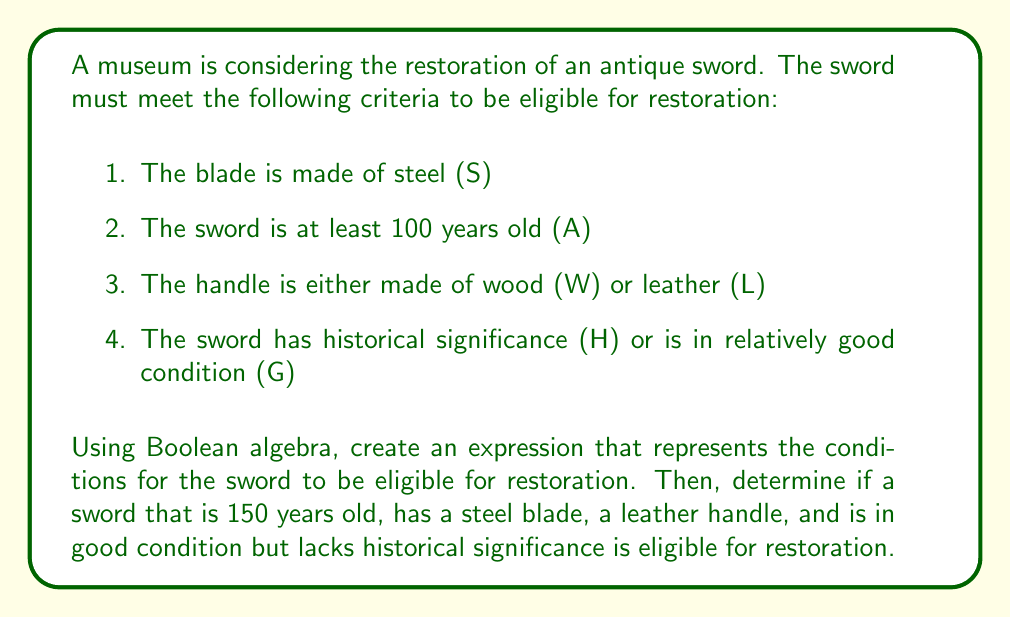Solve this math problem. Let's approach this step-by-step:

1. First, we need to create a Boolean expression for the restoration criteria:

   $$(S \land A) \land (W \lor L) \land (H \lor G)$$

   This expression represents all the conditions that must be met for the sword to be eligible for restoration.

2. Now, let's evaluate the given sword against these criteria:
   - The sword is 150 years old, so A is true.
   - It has a steel blade, so S is true.
   - It has a leather handle, so L is true (and W is false, but we only need one of W or L to be true).
   - It's in good condition but lacks historical significance, so G is true and H is false.

3. Let's substitute these values into our Boolean expression:

   $$(T \land T) \land (F \lor T) \land (F \lor T)$$

4. Simplify:
   - $(T \land T) = T$
   - $(F \lor T) = T$
   - $(F \lor T) = T$

   So our expression becomes:

   $$T \land T \land T = T$$

5. The final result is True, which means the sword is eligible for restoration.
Answer: True 